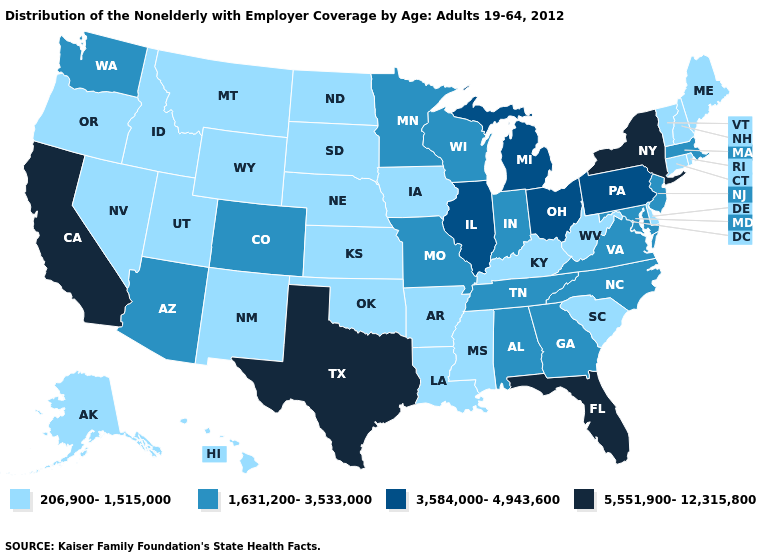Name the states that have a value in the range 5,551,900-12,315,800?
Quick response, please. California, Florida, New York, Texas. What is the value of Iowa?
Write a very short answer. 206,900-1,515,000. What is the value of Idaho?
Answer briefly. 206,900-1,515,000. What is the value of South Carolina?
Quick response, please. 206,900-1,515,000. Does the map have missing data?
Answer briefly. No. Name the states that have a value in the range 206,900-1,515,000?
Quick response, please. Alaska, Arkansas, Connecticut, Delaware, Hawaii, Idaho, Iowa, Kansas, Kentucky, Louisiana, Maine, Mississippi, Montana, Nebraska, Nevada, New Hampshire, New Mexico, North Dakota, Oklahoma, Oregon, Rhode Island, South Carolina, South Dakota, Utah, Vermont, West Virginia, Wyoming. What is the value of Washington?
Short answer required. 1,631,200-3,533,000. Which states have the highest value in the USA?
Be succinct. California, Florida, New York, Texas. Name the states that have a value in the range 3,584,000-4,943,600?
Keep it brief. Illinois, Michigan, Ohio, Pennsylvania. Does Wisconsin have the highest value in the MidWest?
Quick response, please. No. Name the states that have a value in the range 206,900-1,515,000?
Keep it brief. Alaska, Arkansas, Connecticut, Delaware, Hawaii, Idaho, Iowa, Kansas, Kentucky, Louisiana, Maine, Mississippi, Montana, Nebraska, Nevada, New Hampshire, New Mexico, North Dakota, Oklahoma, Oregon, Rhode Island, South Carolina, South Dakota, Utah, Vermont, West Virginia, Wyoming. Name the states that have a value in the range 206,900-1,515,000?
Quick response, please. Alaska, Arkansas, Connecticut, Delaware, Hawaii, Idaho, Iowa, Kansas, Kentucky, Louisiana, Maine, Mississippi, Montana, Nebraska, Nevada, New Hampshire, New Mexico, North Dakota, Oklahoma, Oregon, Rhode Island, South Carolina, South Dakota, Utah, Vermont, West Virginia, Wyoming. What is the highest value in states that border Florida?
Give a very brief answer. 1,631,200-3,533,000. Name the states that have a value in the range 1,631,200-3,533,000?
Short answer required. Alabama, Arizona, Colorado, Georgia, Indiana, Maryland, Massachusetts, Minnesota, Missouri, New Jersey, North Carolina, Tennessee, Virginia, Washington, Wisconsin. 